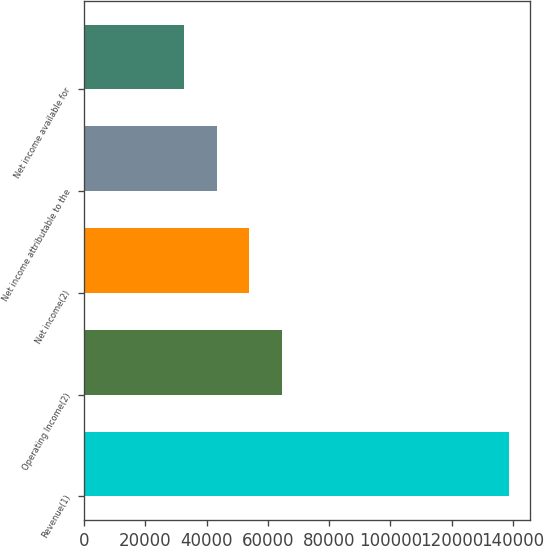Convert chart. <chart><loc_0><loc_0><loc_500><loc_500><bar_chart><fcel>Revenue(1)<fcel>Operating Income(2)<fcel>Net income(2)<fcel>Net income attributable to the<fcel>Net income available for<nl><fcel>138748<fcel>64501.1<fcel>53894.4<fcel>43287.7<fcel>32681<nl></chart> 